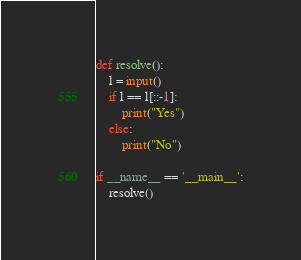<code> <loc_0><loc_0><loc_500><loc_500><_Python_>def resolve():
    l = input()
    if l == l[::-1]:
        print("Yes")
    else:
        print("No")

if __name__ == '__main__':
    resolve()</code> 